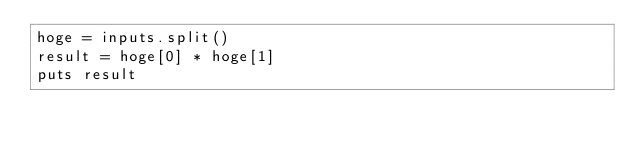<code> <loc_0><loc_0><loc_500><loc_500><_Ruby_>hoge = inputs.split()
result = hoge[0] * hoge[1]
puts result</code> 